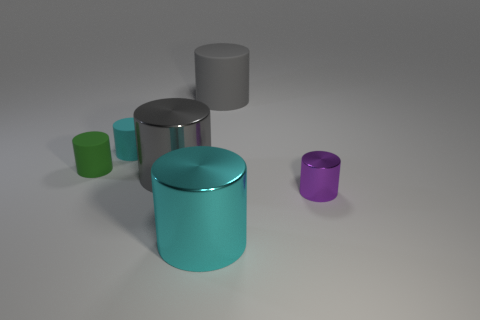Which object stands out the most to you and why? The large silver cylinder in the center stands out due to its reflective surface and prominent placement. It contrasts with the other objects, which have matte finishes, drawing the viewer's attention. 